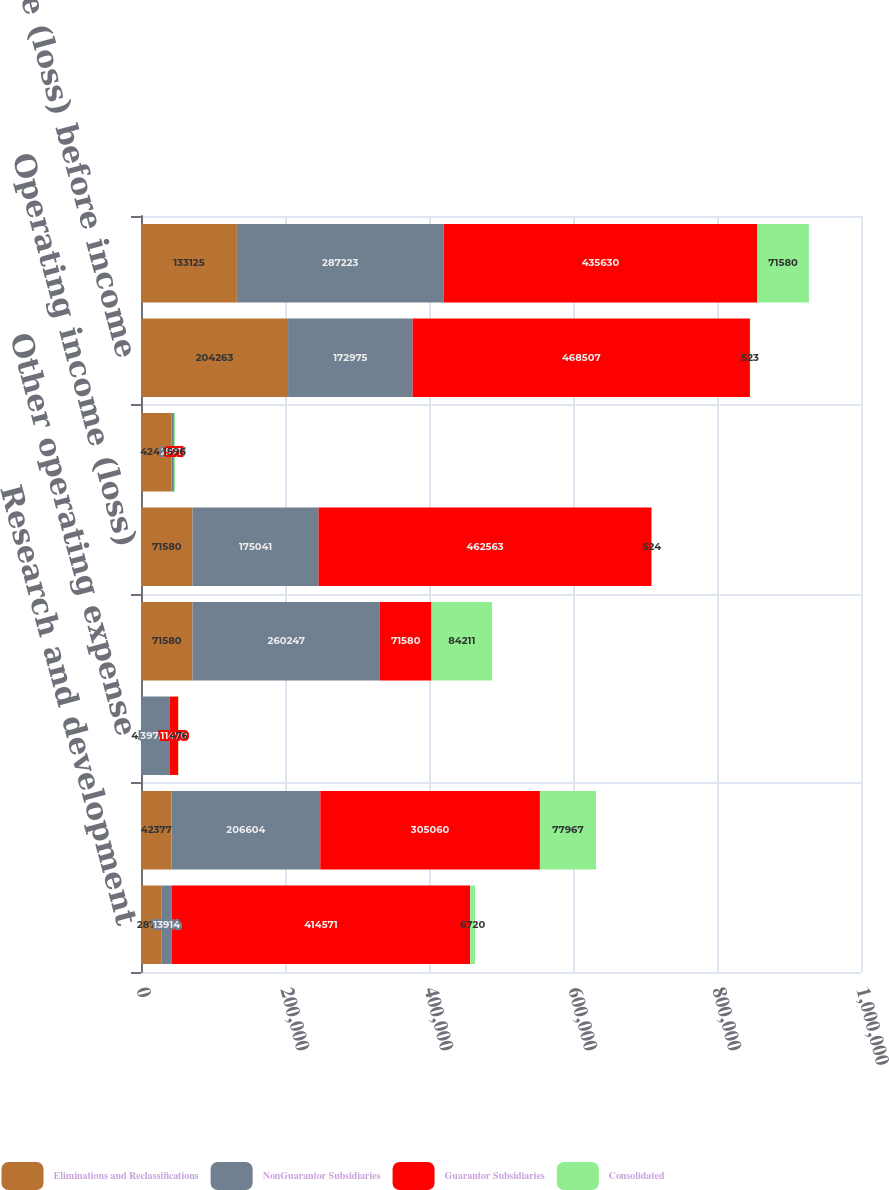Convert chart to OTSL. <chart><loc_0><loc_0><loc_500><loc_500><stacked_bar_chart><ecel><fcel>Research and development<fcel>Selling general and<fcel>Other operating expense<fcel>Total operating expenses<fcel>Operating income (loss)<fcel>Interest expense<fcel>Income (loss) before income<fcel>Net income<nl><fcel>Eliminations and Reclassifications<fcel>28717<fcel>42377<fcel>486<fcel>71580<fcel>71580<fcel>42482<fcel>204263<fcel>133125<nl><fcel>NonGuarantor Subsidiaries<fcel>13914<fcel>206604<fcel>39729<fcel>260247<fcel>175041<fcel>2106<fcel>172975<fcel>287223<nl><fcel>Guarantor Subsidiaries<fcel>414571<fcel>305060<fcel>11470<fcel>71580<fcel>462563<fcel>971<fcel>468507<fcel>435630<nl><fcel>Consolidated<fcel>6720<fcel>77967<fcel>476<fcel>84211<fcel>524<fcel>1596<fcel>523<fcel>71580<nl></chart> 